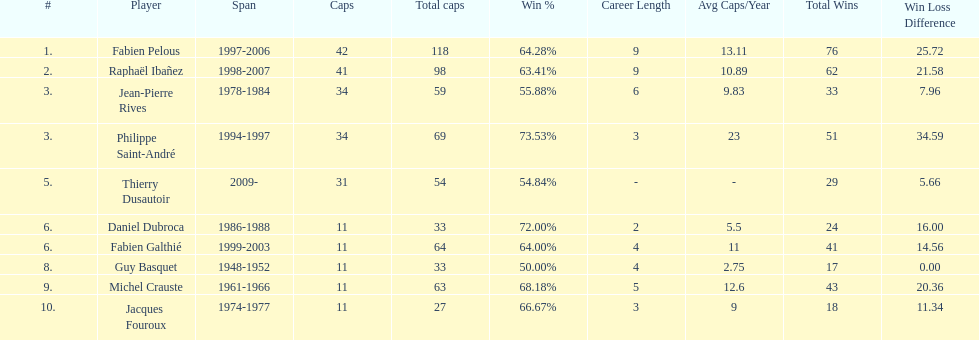Which captain served the least amount of time? Daniel Dubroca. 